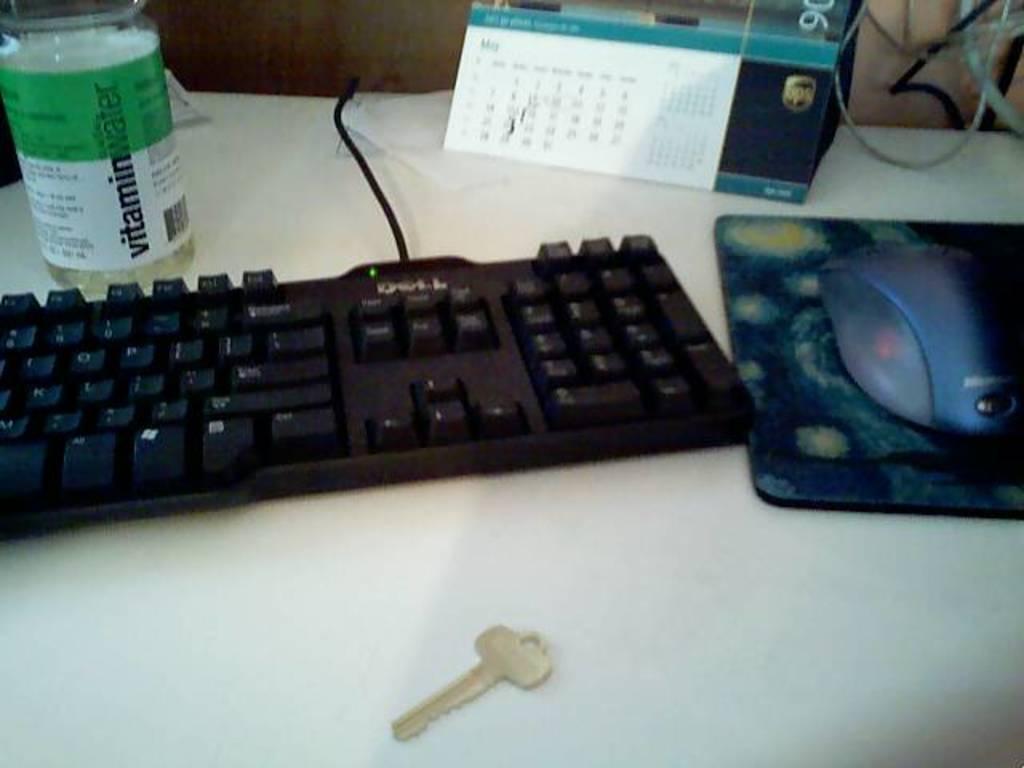What brand of drink is near the keyboard?
Your answer should be compact. Vitamin water. Key board is there?
Offer a terse response. Yes. 